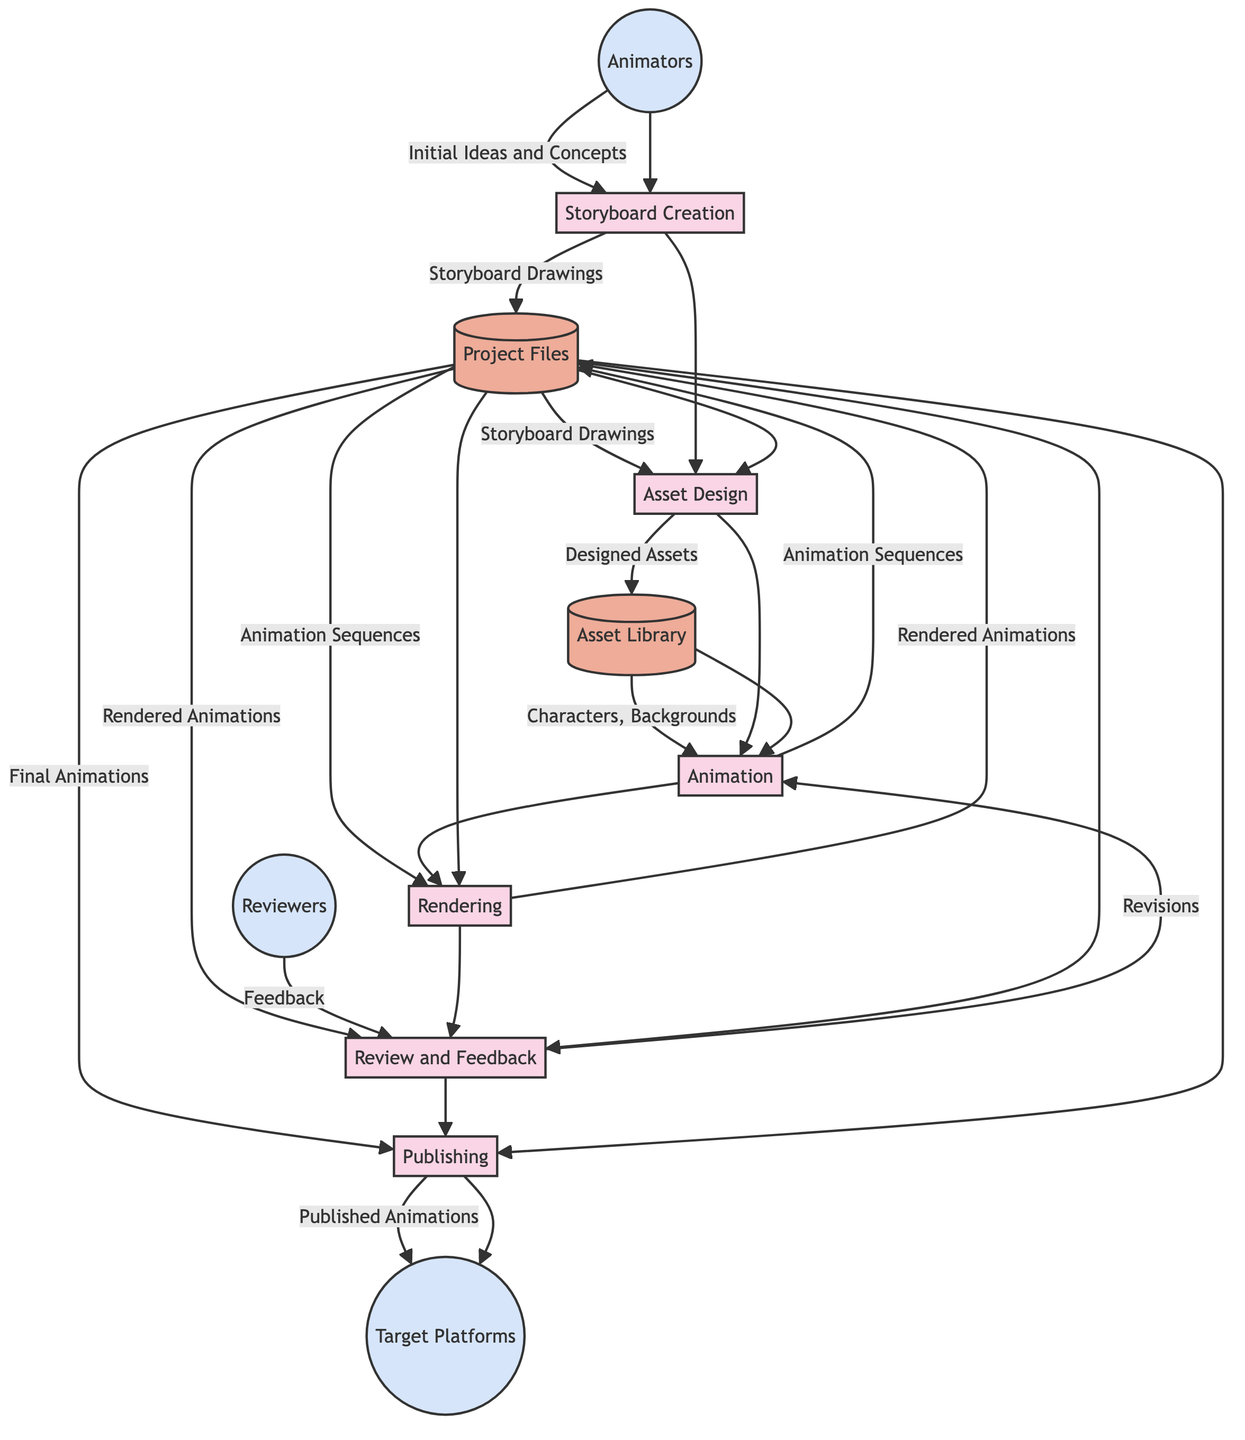What is the first process in the workflow? The first process is indicated in the diagram as the point where the Animators feed their initial ideas and concepts. This process is labeled "Storyboard Creation."
Answer: Storyboard Creation How many data stores are present in the diagram? Upon examining the diagram, we can count the specific nodes marked as data stores, which include "Asset Library" and "Project Files." Thus, there are two data stores.
Answer: 2 Which external entity provides feedback during the review process? The diagram specifies that the external entity labeled "Reviewers" is the one that provides feedback at the "Review and Feedback" stage of the workflow.
Answer: Reviewers What data flows from the Animation process to Project Files? The flow from the Animation process to Project Files is indicated in the diagram as "Animation Sequences," showing the specific data generated at that stage.
Answer: Animation Sequences Which process follows the Rendering process? The diagram flows from "Rendering" directly to "Review and Feedback," indicating that the review stage is the next process after rendering the animations.
Answer: Review and Feedback How does the Asset Library interact with the Animation process? The diagram shows that the "Asset Library" supplies data in the form of "Characters, Backgrounds" to the "Animation" process, indicating a directional flow from the library to animation creation.
Answer: Characters, Backgrounds What is the purpose of the Review and Feedback process? The purpose of the "Review and Feedback" process is to collect feedback on the rendered animations, as indicated by the input labeled "Rendered Animations" from Project Files, and subsequently send "Revisions" back to the Animation process.
Answer: Feedback What is the final stage in the workflow? The final stage of the workflow, as indicated in the diagram, is the "Publishing" process, which results in the output being "Published Animations" to the target platforms.
Answer: Publishing 